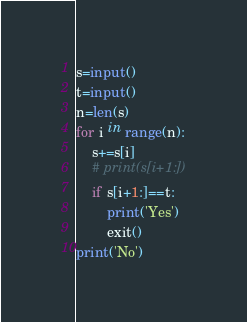Convert code to text. <code><loc_0><loc_0><loc_500><loc_500><_Python_>s=input()
t=input()
n=len(s)
for i in range(n):
    s+=s[i]
    # print(s[i+1:])
    if s[i+1:]==t:
        print('Yes')
        exit()
print('No')</code> 